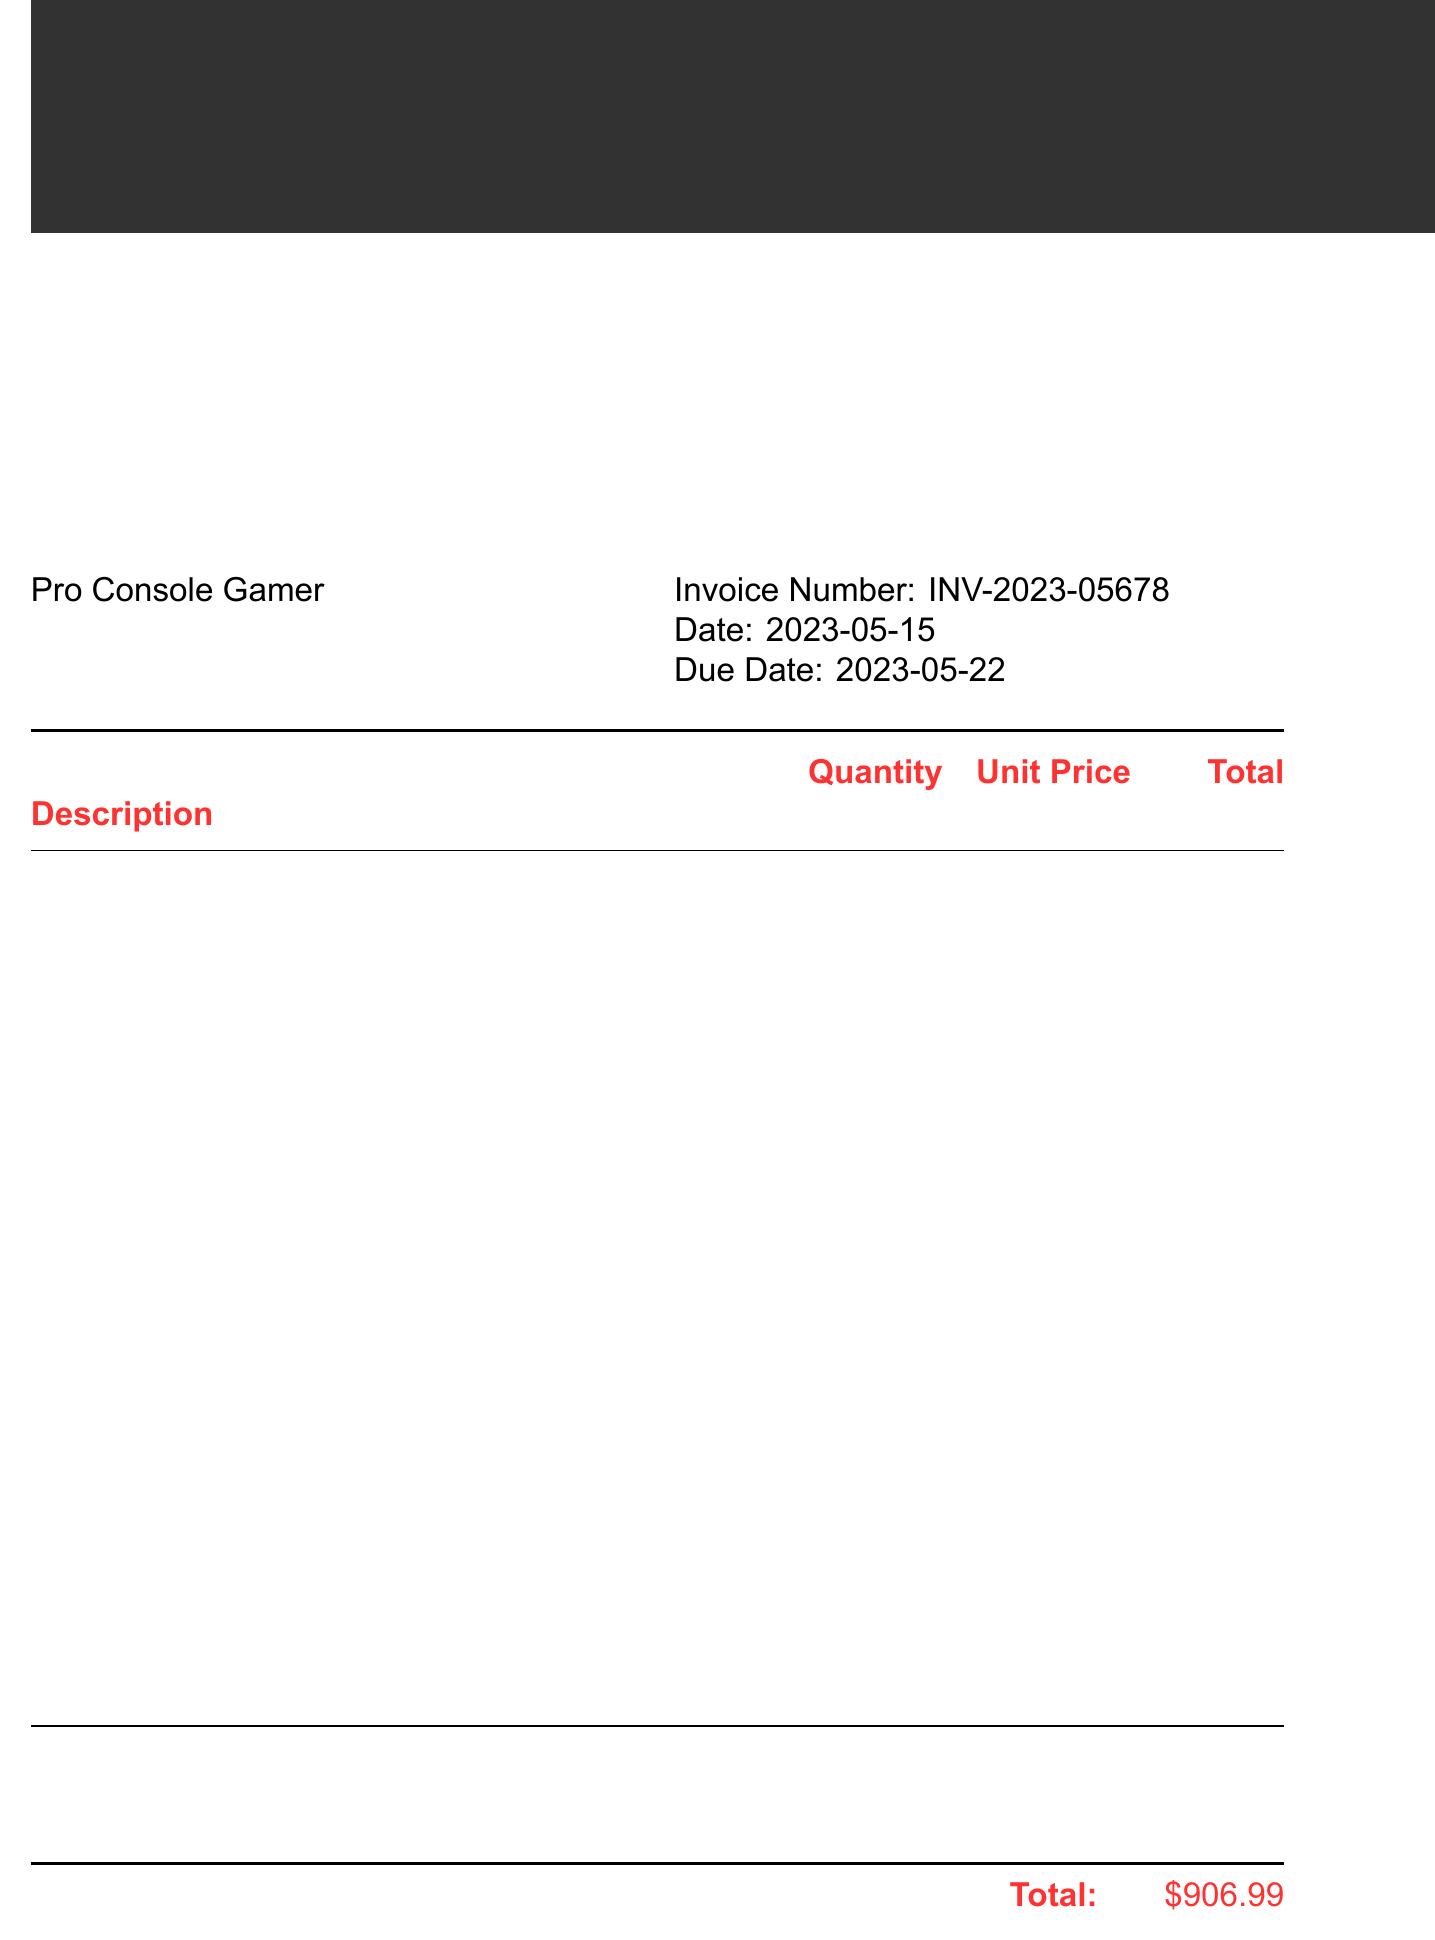what is the merchant name? The merchant name listed in the document is the entity providing the gaming subscriptions, which is Ultimate Gamer's Hub.
Answer: Ultimate Gamer's Hub who is the customer? The customer is the individual or entity receiving the invoice, identified as Pro Console Gamer.
Answer: Pro Console Gamer what is the invoice number? The invoice number is a unique identifier for the transaction provided in the document, stated as INV-2023-05678.
Answer: INV-2023-05678 what is the due date for payment? The due date indicates when the payment for the invoice is expected, which is specified as May 22, 2023.
Answer: 2023-05-22 how much is the total amount due? The total amount due is the final amount to be paid for all subscriptions and services, which is shown as $906.99.
Answer: $906.99 what is the tax rate applied? The tax rate is a percentage that indicates how much tax has been applied to the subtotal, provided as 8%.
Answer: 8% how many items are listed in the invoice? The total number of different subscriptions and services listed in the invoice suggests the range of products that have been purchased, which is eight items.
Answer: 8 what is the payment method used? The payment method indicates how the transaction was completed and is specified as Credit Card (VISA ****1234).
Answer: Credit Card (VISA ****1234) what is stated in the notes section? The notes section provides additional information or thanks to the customer, which is a message expressing gratitude for choosing Ultimate Gamer's Hub.
Answer: Thank you for choosing Ultimate Gamer's Hub for your premium gaming subscriptions. Enjoy a year of unparalleled access to the best console and PC gaming experiences! 